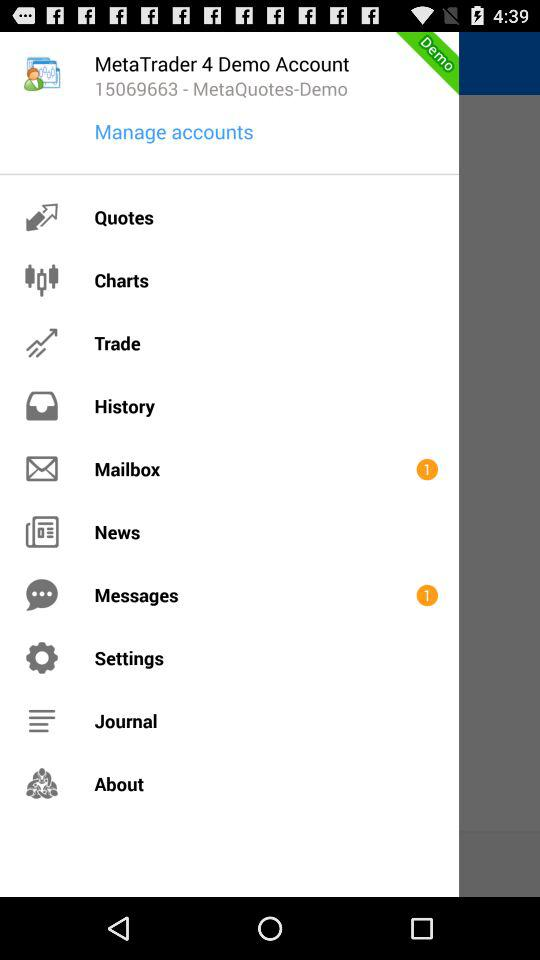How many demo accounts are there? There are 4 demo accounts. 